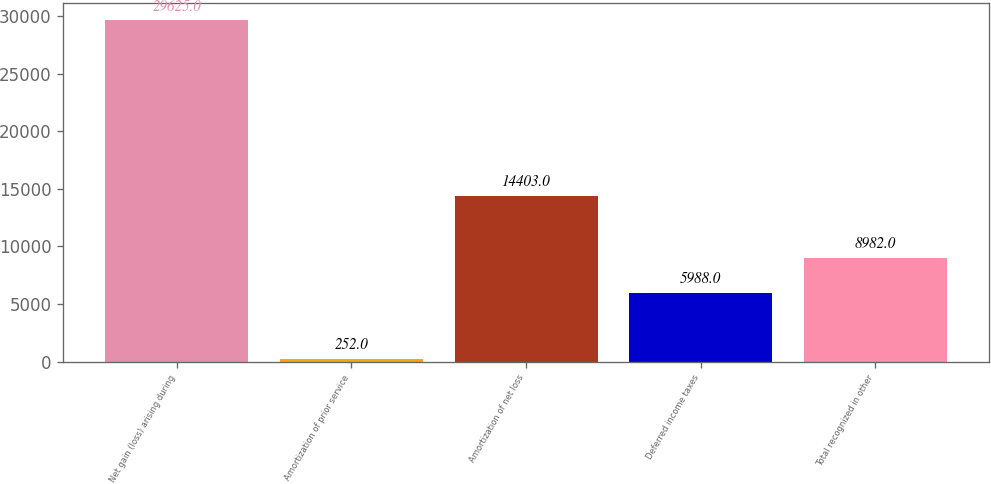Convert chart to OTSL. <chart><loc_0><loc_0><loc_500><loc_500><bar_chart><fcel>Net gain (loss) arising during<fcel>Amortization of prior service<fcel>Amortization of net loss<fcel>Deferred income taxes<fcel>Total recognized in other<nl><fcel>29625<fcel>252<fcel>14403<fcel>5988<fcel>8982<nl></chart> 